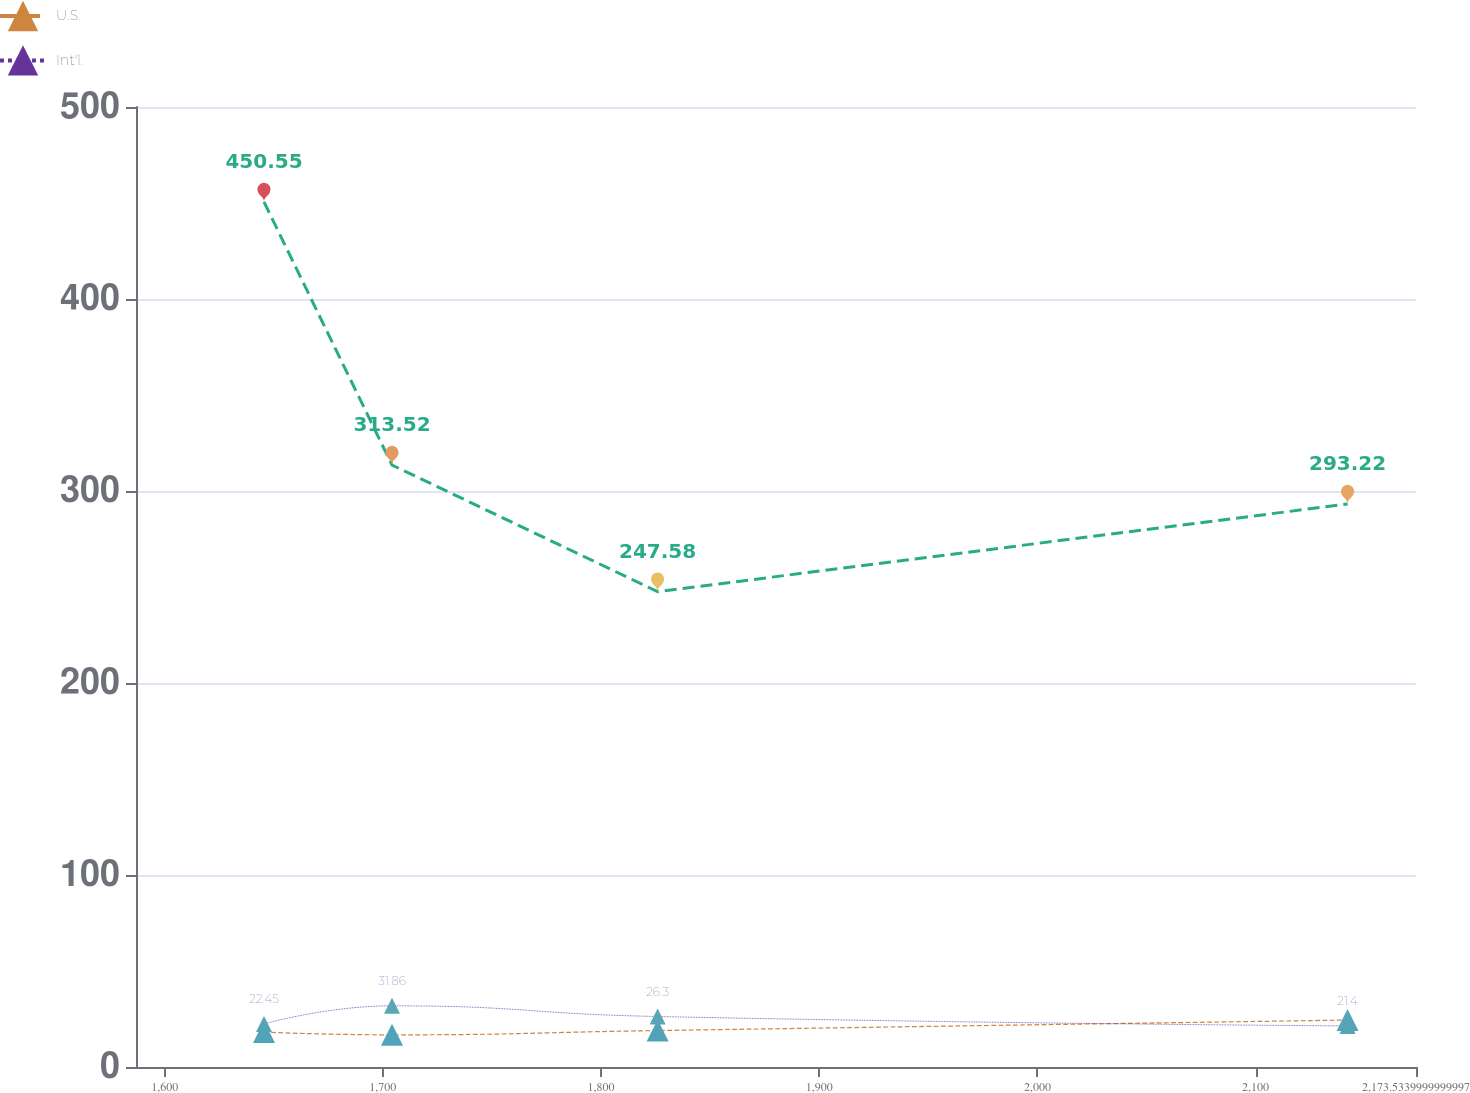Convert chart to OTSL. <chart><loc_0><loc_0><loc_500><loc_500><line_chart><ecel><fcel>Unnamed: 1<fcel>U.S.<fcel>Int'l.<nl><fcel>1645.54<fcel>450.55<fcel>18.17<fcel>22.45<nl><fcel>1704.21<fcel>313.52<fcel>16.75<fcel>31.86<nl><fcel>1825.94<fcel>247.58<fcel>18.98<fcel>26.3<nl><fcel>2142.17<fcel>293.22<fcel>24.45<fcel>21.4<nl><fcel>2232.2<fcel>333.82<fcel>23.43<fcel>25.25<nl></chart> 